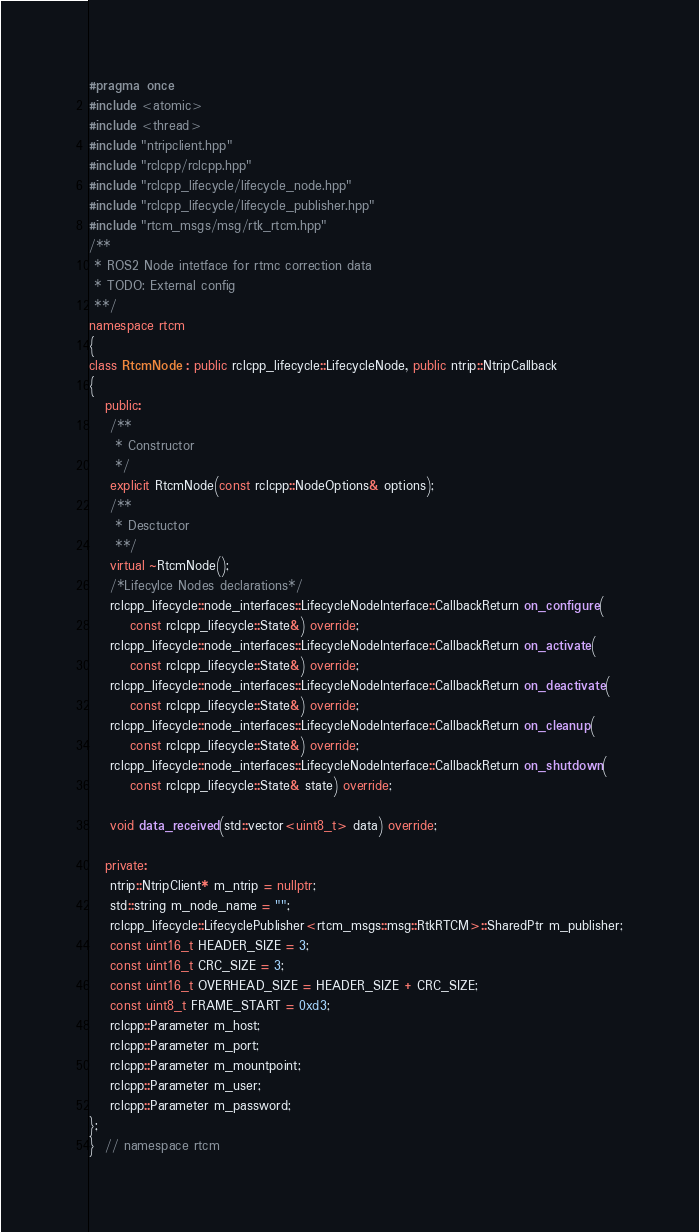<code> <loc_0><loc_0><loc_500><loc_500><_C++_>#pragma once
#include <atomic>
#include <thread>
#include "ntripclient.hpp"
#include "rclcpp/rclcpp.hpp"
#include "rclcpp_lifecycle/lifecycle_node.hpp"
#include "rclcpp_lifecycle/lifecycle_publisher.hpp"
#include "rtcm_msgs/msg/rtk_rtcm.hpp"
/**
 * ROS2 Node intetface for rtmc correction data
 * TODO: External config
 **/
namespace rtcm
{
class RtcmNode : public rclcpp_lifecycle::LifecycleNode, public ntrip::NtripCallback
{
   public:
    /**
     * Constructor
     */
    explicit RtcmNode(const rclcpp::NodeOptions& options);
    /**
     * Desctuctor
     **/
    virtual ~RtcmNode();
    /*Lifecylce Nodes declarations*/
    rclcpp_lifecycle::node_interfaces::LifecycleNodeInterface::CallbackReturn on_configure(
        const rclcpp_lifecycle::State&) override;
    rclcpp_lifecycle::node_interfaces::LifecycleNodeInterface::CallbackReturn on_activate(
        const rclcpp_lifecycle::State&) override;
    rclcpp_lifecycle::node_interfaces::LifecycleNodeInterface::CallbackReturn on_deactivate(
        const rclcpp_lifecycle::State&) override;
    rclcpp_lifecycle::node_interfaces::LifecycleNodeInterface::CallbackReturn on_cleanup(
        const rclcpp_lifecycle::State&) override;
    rclcpp_lifecycle::node_interfaces::LifecycleNodeInterface::CallbackReturn on_shutdown(
        const rclcpp_lifecycle::State& state) override;

    void data_received(std::vector<uint8_t> data) override;

   private:
    ntrip::NtripClient* m_ntrip = nullptr;
    std::string m_node_name = "";
    rclcpp_lifecycle::LifecyclePublisher<rtcm_msgs::msg::RtkRTCM>::SharedPtr m_publisher;
    const uint16_t HEADER_SIZE = 3;
    const uint16_t CRC_SIZE = 3;
    const uint16_t OVERHEAD_SIZE = HEADER_SIZE + CRC_SIZE;
    const uint8_t FRAME_START = 0xd3;
    rclcpp::Parameter m_host;
    rclcpp::Parameter m_port;
    rclcpp::Parameter m_mountpoint;
    rclcpp::Parameter m_user;
    rclcpp::Parameter m_password;
};
}  // namespace rtcm
</code> 